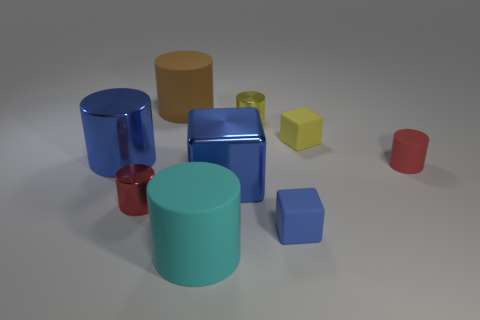Can you describe the texture and appearance of the cyan cylinder? Certainly! The cyan cylinder has a matte rubberized appearance which scatters the light softly, giving it a less reflective surface compared to the metallic objects. 